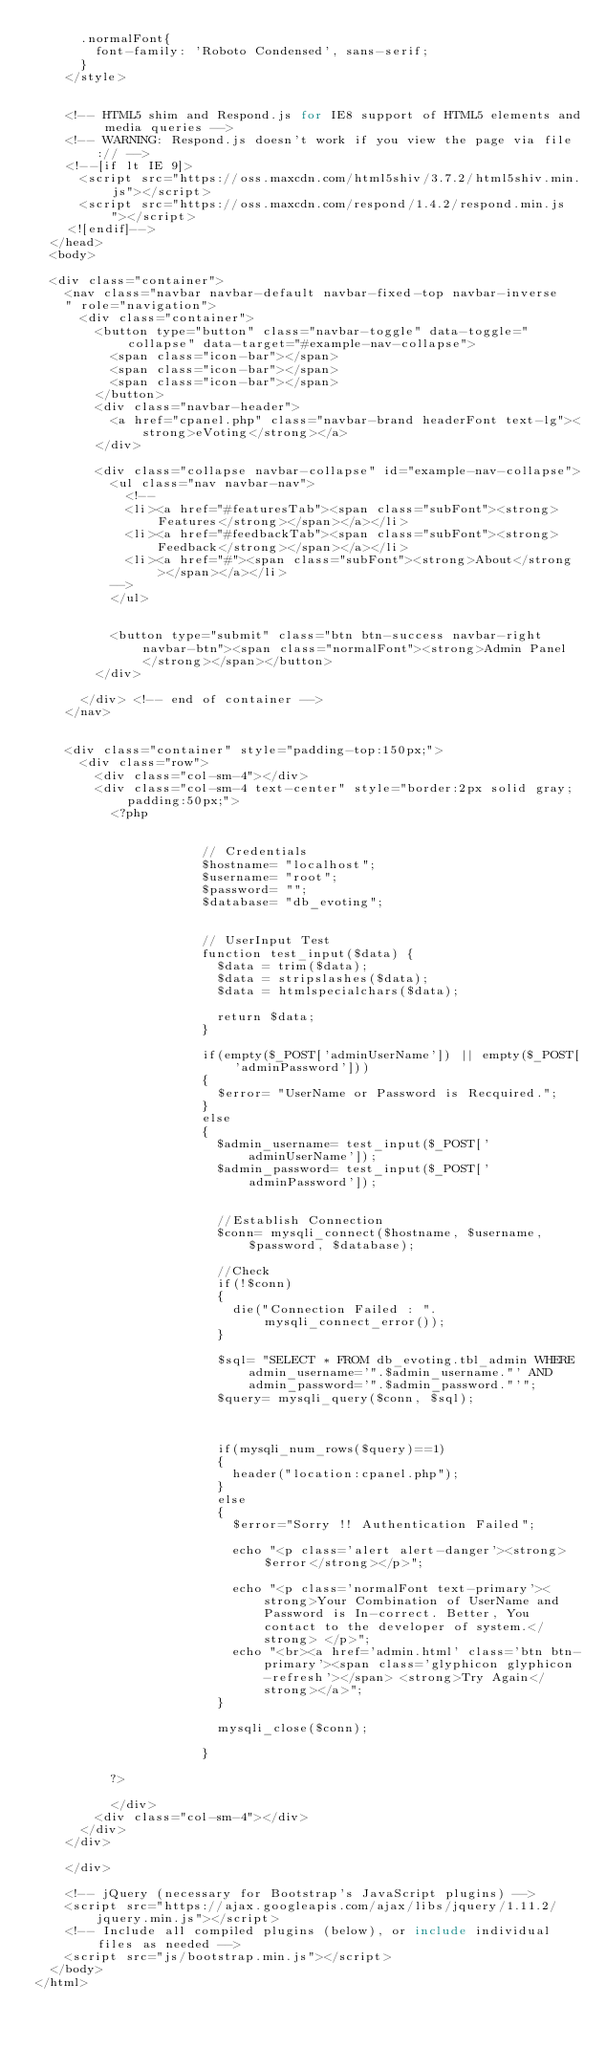Convert code to text. <code><loc_0><loc_0><loc_500><loc_500><_PHP_>      .normalFont{
        font-family: 'Roboto Condensed', sans-serif;
      }
    </style>


    <!-- HTML5 shim and Respond.js for IE8 support of HTML5 elements and media queries -->
    <!-- WARNING: Respond.js doesn't work if you view the page via file:// -->
    <!--[if lt IE 9]>
      <script src="https://oss.maxcdn.com/html5shiv/3.7.2/html5shiv.min.js"></script>
      <script src="https://oss.maxcdn.com/respond/1.4.2/respond.min.js"></script>
    <![endif]-->
  </head>
  <body>
  
  <div class="container">
    <nav class="navbar navbar-default navbar-fixed-top navbar-inverse
    " role="navigation">
      <div class="container">
        <button type="button" class="navbar-toggle" data-toggle="collapse" data-target="#example-nav-collapse">
          <span class="icon-bar"></span>
          <span class="icon-bar"></span>
          <span class="icon-bar"></span>
        </button>
        <div class="navbar-header">
          <a href="cpanel.php" class="navbar-brand headerFont text-lg"><strong>eVoting</strong></a>
        </div>

        <div class="collapse navbar-collapse" id="example-nav-collapse">
          <ul class="nav navbar-nav">
            <!-- 
            <li><a href="#featuresTab"><span class="subFont"><strong>Features</strong></span></a></li>
            <li><a href="#feedbackTab"><span class="subFont"><strong>Feedback</strong></span></a></li>
            <li><a href="#"><span class="subFont"><strong>About</strong></span></a></li>
          -->
          </ul>
          

          <button type="submit" class="btn btn-success navbar-right navbar-btn"><span class="normalFont"><strong>Admin Panel</strong></span></button>
        </div>

      </div> <!-- end of container -->
    </nav>

    
    <div class="container" style="padding-top:150px;">
      <div class="row">
        <div class="col-sm-4"></div>
        <div class="col-sm-4 text-center" style="border:2px solid gray;padding:50px;">
          <?php
                    

                      // Credentials
                      $hostname= "localhost";
                      $username= "root";
                      $password= "";
                      $database= "db_evoting";


                      // UserInput Test
                      function test_input($data) {
                        $data = trim($data);
                        $data = stripslashes($data);
                        $data = htmlspecialchars($data);
                       
                        return $data;
                      } 

                      if(empty($_POST['adminUserName']) || empty($_POST['adminPassword']))
                      {
                        $error= "UserName or Password is Recquired.";
                      }
                      else
                      {
                        $admin_username= test_input($_POST['adminUserName']);
                        $admin_password= test_input($_POST['adminPassword']);


                        //Establish Connection
                        $conn= mysqli_connect($hostname, $username, $password, $database);

                        //Check
                        if(!$conn)
                        {
                          die("Connection Failed : ".mysqli_connect_error());
                        }

                        $sql= "SELECT * FROM db_evoting.tbl_admin WHERE admin_username='".$admin_username."' AND admin_password='".$admin_password."'";
                        $query= mysqli_query($conn, $sql);
                       

                        
                        if(mysqli_num_rows($query)==1)
                        {
                          header("location:cpanel.php");
                        }
                        else
                        {
                          $error="Sorry !! Authentication Failed";
                          
                          echo "<p class='alert alert-danger'><strong>$error</strong></p>";

                          echo "<p class='normalFont text-primary'><strong>Your Combination of UserName and Password is In-correct. Better, You contact to the developer of system.</strong> </p>";
                          echo "<br><a href='admin.html' class='btn btn-primary'><span class='glyphicon glyphicon-refresh'></span> <strong>Try Again</strong></a>";
                        }

                        mysqli_close($conn);

                      }
                    
          ?>

          </div>
        <div class="col-sm-4"></div>
      </div>
    </div>

    </div>

    <!-- jQuery (necessary for Bootstrap's JavaScript plugins) -->
    <script src="https://ajax.googleapis.com/ajax/libs/jquery/1.11.2/jquery.min.js"></script>
    <!-- Include all compiled plugins (below), or include individual files as needed -->
    <script src="js/bootstrap.min.js"></script>
  </body>
</html>


</code> 